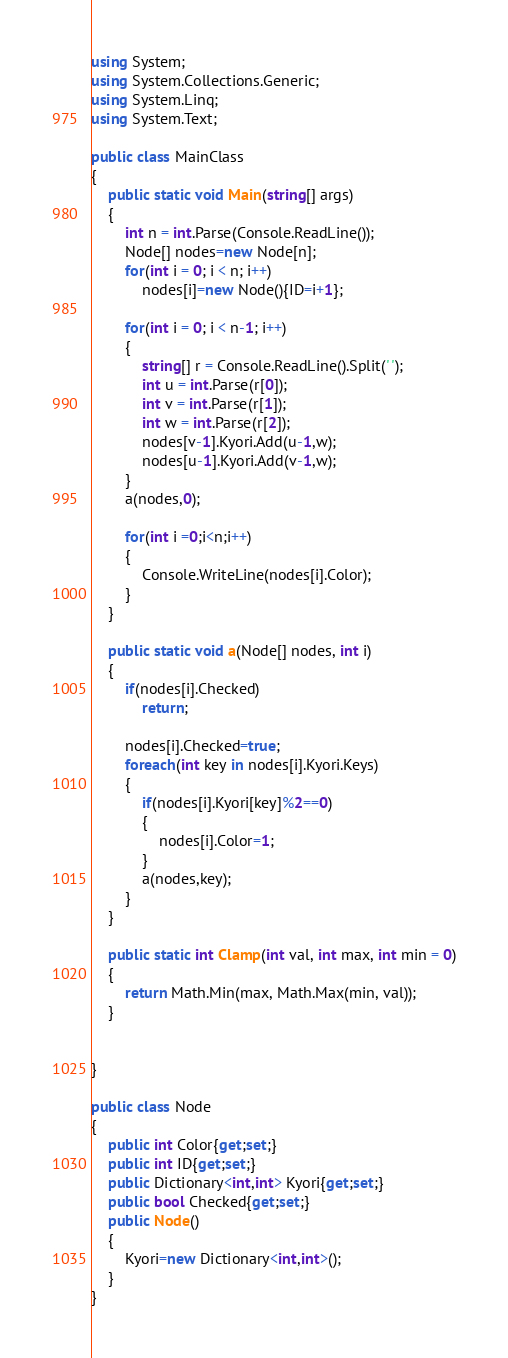Convert code to text. <code><loc_0><loc_0><loc_500><loc_500><_C#_>using System;
using System.Collections.Generic;
using System.Linq;
using System.Text;

public class MainClass
{
	public static void Main(string[] args)
	{
		int n = int.Parse(Console.ReadLine());
		Node[] nodes=new Node[n];
		for(int i = 0; i < n; i++)
			nodes[i]=new Node(){ID=i+1};
			
		for(int i = 0; i < n-1; i++)
		{
			string[] r = Console.ReadLine().Split(' ');
			int u = int.Parse(r[0]);
			int v = int.Parse(r[1]);
			int w = int.Parse(r[2]);
			nodes[v-1].Kyori.Add(u-1,w);
			nodes[u-1].Kyori.Add(v-1,w);
		}
		a(nodes,0);
		
		for(int i =0;i<n;i++)
		{
			Console.WriteLine(nodes[i].Color);
		}
	}

	public static void a(Node[] nodes, int i)
	{
		if(nodes[i].Checked)
			return;
		
		nodes[i].Checked=true;
		foreach(int key in nodes[i].Kyori.Keys)
		{
			if(nodes[i].Kyori[key]%2==0)
			{
				nodes[i].Color=1;
			}
			a(nodes,key);
		}
	}
	
	public static int Clamp(int val, int max, int min = 0)
	{
		return Math.Min(max, Math.Max(min, val));
	}


}

public class Node
{
	public int Color{get;set;}
	public int ID{get;set;}
	public Dictionary<int,int> Kyori{get;set;}
	public bool Checked{get;set;}
	public Node()
	{
		Kyori=new Dictionary<int,int>();
	}
}
</code> 